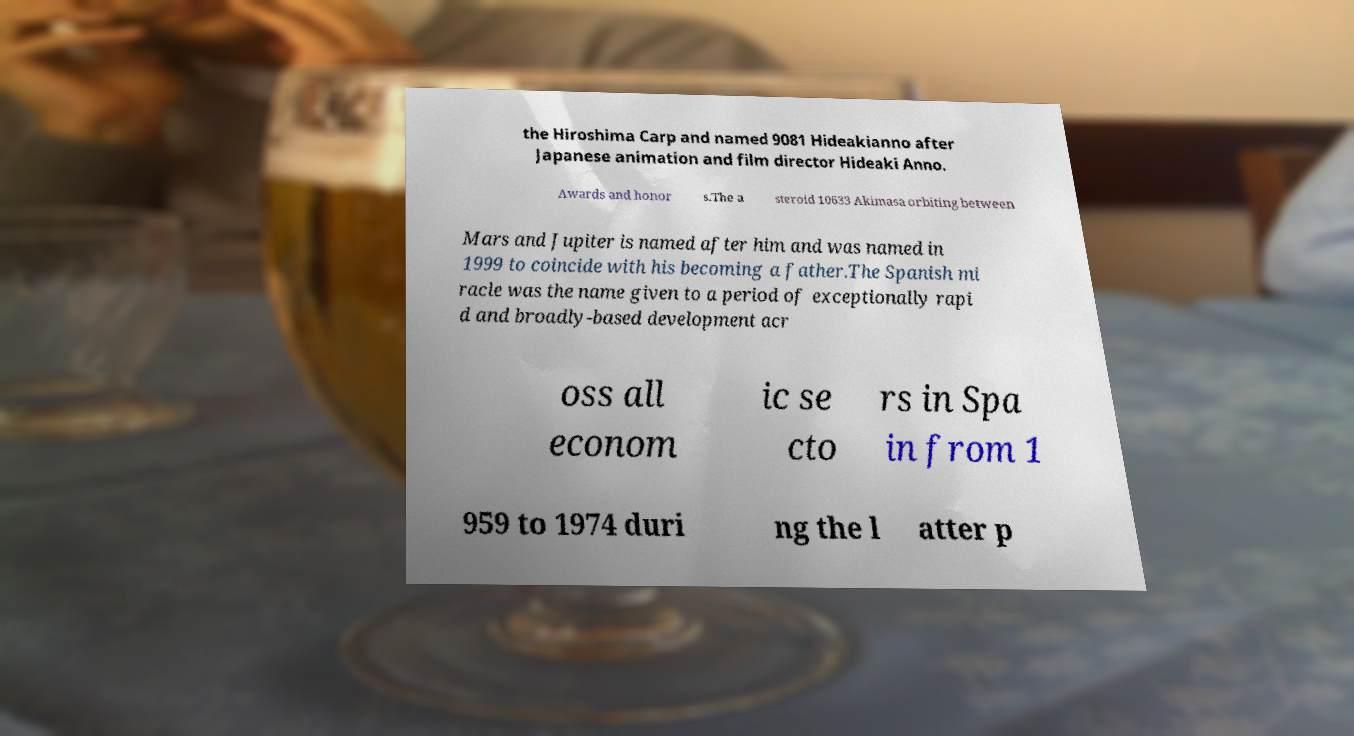What messages or text are displayed in this image? I need them in a readable, typed format. the Hiroshima Carp and named 9081 Hideakianno after Japanese animation and film director Hideaki Anno. Awards and honor s.The a steroid 10633 Akimasa orbiting between Mars and Jupiter is named after him and was named in 1999 to coincide with his becoming a father.The Spanish mi racle was the name given to a period of exceptionally rapi d and broadly-based development acr oss all econom ic se cto rs in Spa in from 1 959 to 1974 duri ng the l atter p 